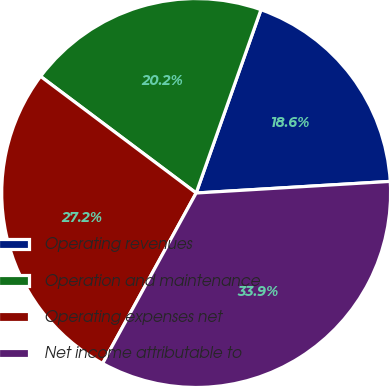Convert chart to OTSL. <chart><loc_0><loc_0><loc_500><loc_500><pie_chart><fcel>Operating revenues<fcel>Operation and maintenance<fcel>Operating expenses net<fcel>Net income attributable to<nl><fcel>18.64%<fcel>20.17%<fcel>27.25%<fcel>33.94%<nl></chart> 